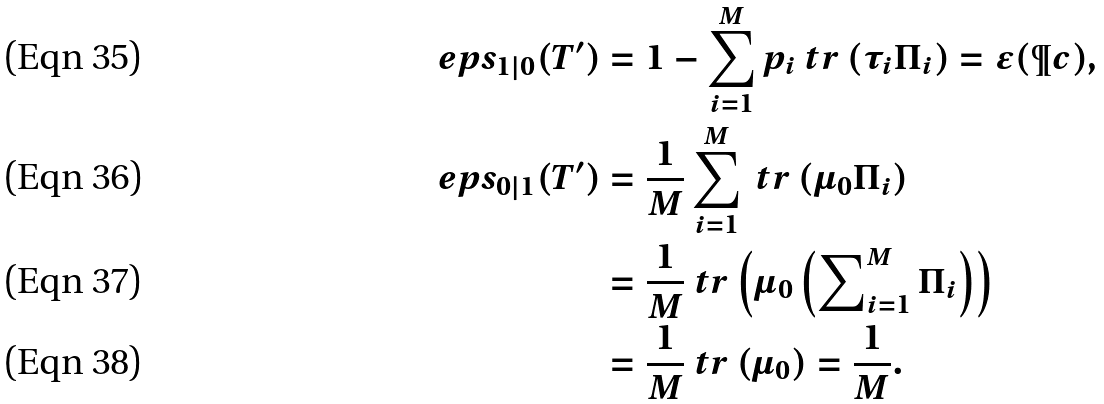Convert formula to latex. <formula><loc_0><loc_0><loc_500><loc_500>\ e p s _ { 1 | 0 } ( T ^ { \prime } ) & = 1 - \sum _ { i = 1 } ^ { M } p _ { i } \ t r \left ( \tau _ { i } \Pi _ { i } \right ) = \epsilon ( \P c ) , \\ \ e p s _ { 0 | 1 } ( T ^ { \prime } ) & = \frac { 1 } { M } \sum _ { i = 1 } ^ { M } \ t r \left ( \mu _ { 0 } \Pi _ { i } \right ) \\ & = \frac { 1 } { M } \ t r \left ( \mu _ { 0 } \left ( \sum \nolimits _ { i = 1 } ^ { M } \Pi _ { i } \right ) \right ) \\ & = \frac { 1 } { M } \ t r \left ( \mu _ { 0 } \right ) = \frac { 1 } { M } .</formula> 